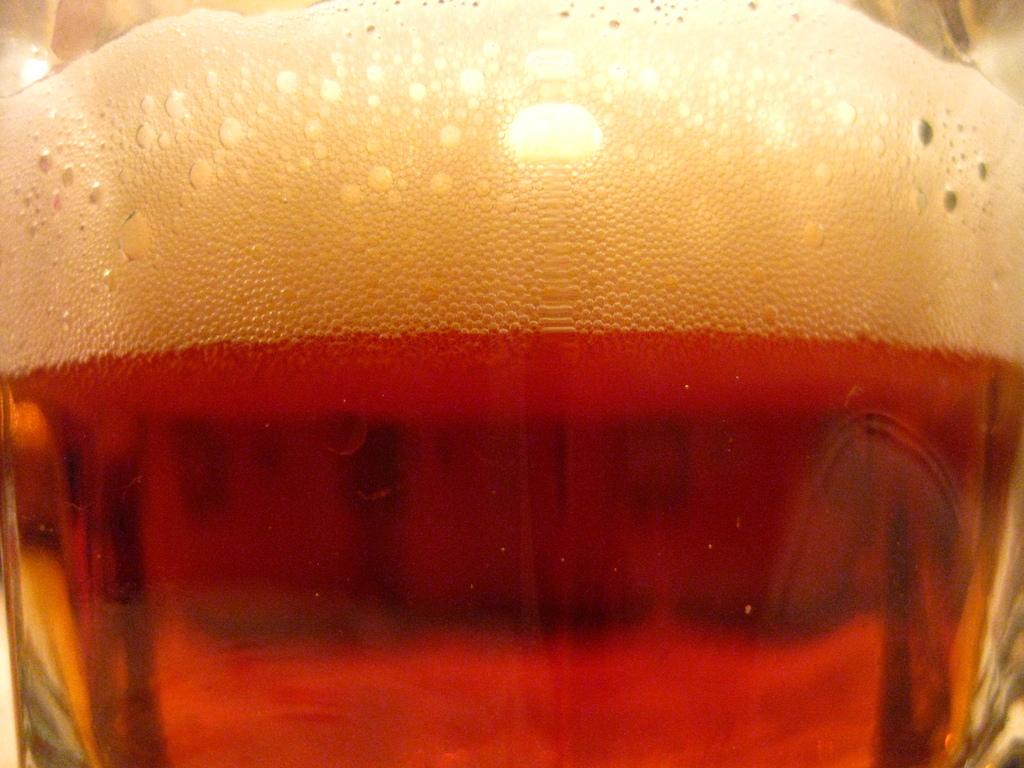What is contained in the glass in the image? There is liquid in a glass in the image. What type of punishment is being administered in the image? There is no punishment being administered in the image; it only shows a glass containing liquid. What kind of list is being referenced in the image? There is no list present in the image; it only shows a glass containing liquid. 